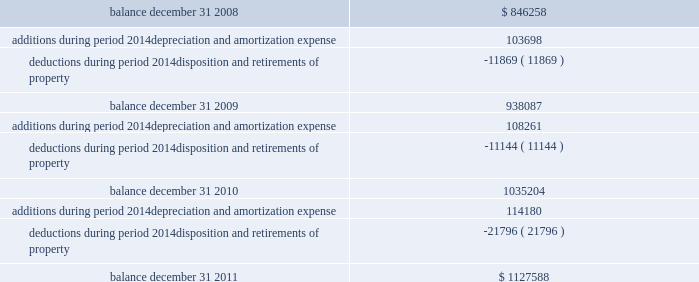Federal realty investment trust schedule iii summary of real estate and accumulated depreciation - continued three years ended december 31 , 2011 reconciliation of accumulated depreciation and amortization ( in thousands ) balance , december 31 , 2008................................................................................................................................... .
Additions during period 2014depreciation and amortization expense .................................................................... .
Deductions during period 2014disposition and retirements of property ................................................................. .
Balance , december 31 , 2009................................................................................................................................... .
Additions during period 2014depreciation and amortization expense .................................................................... .
Deductions during period 2014disposition and retirements of property ................................................................. .
Balance , december 31 , 2010................................................................................................................................... .
Additions during period 2014depreciation and amortization expense .................................................................... .
Deductions during period 2014disposition and retirements of property ................................................................. .
Balance , december 31 , 2011................................................................................................................................... .
$ 846258 103698 ( 11869 ) 938087 108261 ( 11144 ) 1035204 114180 ( 21796 ) $ 1127588 .
Federal realty investment trust schedule iii summary of real estate and accumulated depreciation - continued three years ended december 31 , 2011 reconciliation of accumulated depreciation and amortization ( in thousands ) balance , december 31 , 2008................................................................................................................................... .
Additions during period 2014depreciation and amortization expense .................................................................... .
Deductions during period 2014disposition and retirements of property ................................................................. .
Balance , december 31 , 2009................................................................................................................................... .
Additions during period 2014depreciation and amortization expense .................................................................... .
Deductions during period 2014disposition and retirements of property ................................................................. .
Balance , december 31 , 2010................................................................................................................................... .
Additions during period 2014depreciation and amortization expense .................................................................... .
Deductions during period 2014disposition and retirements of property ................................................................. .
Balance , december 31 , 2011................................................................................................................................... .
$ 846258 103698 ( 11869 ) 938087 108261 ( 11144 ) 1035204 114180 ( 21796 ) $ 1127588 .
Considering the years 2008-2010 , what is the value of the average deductions?\\n? 
Rationale: it is the sum of all deductions divided by the sum of the years .
Computations: (((11869 + 11144) + 21796) / 3)
Answer: 14936.33333. 